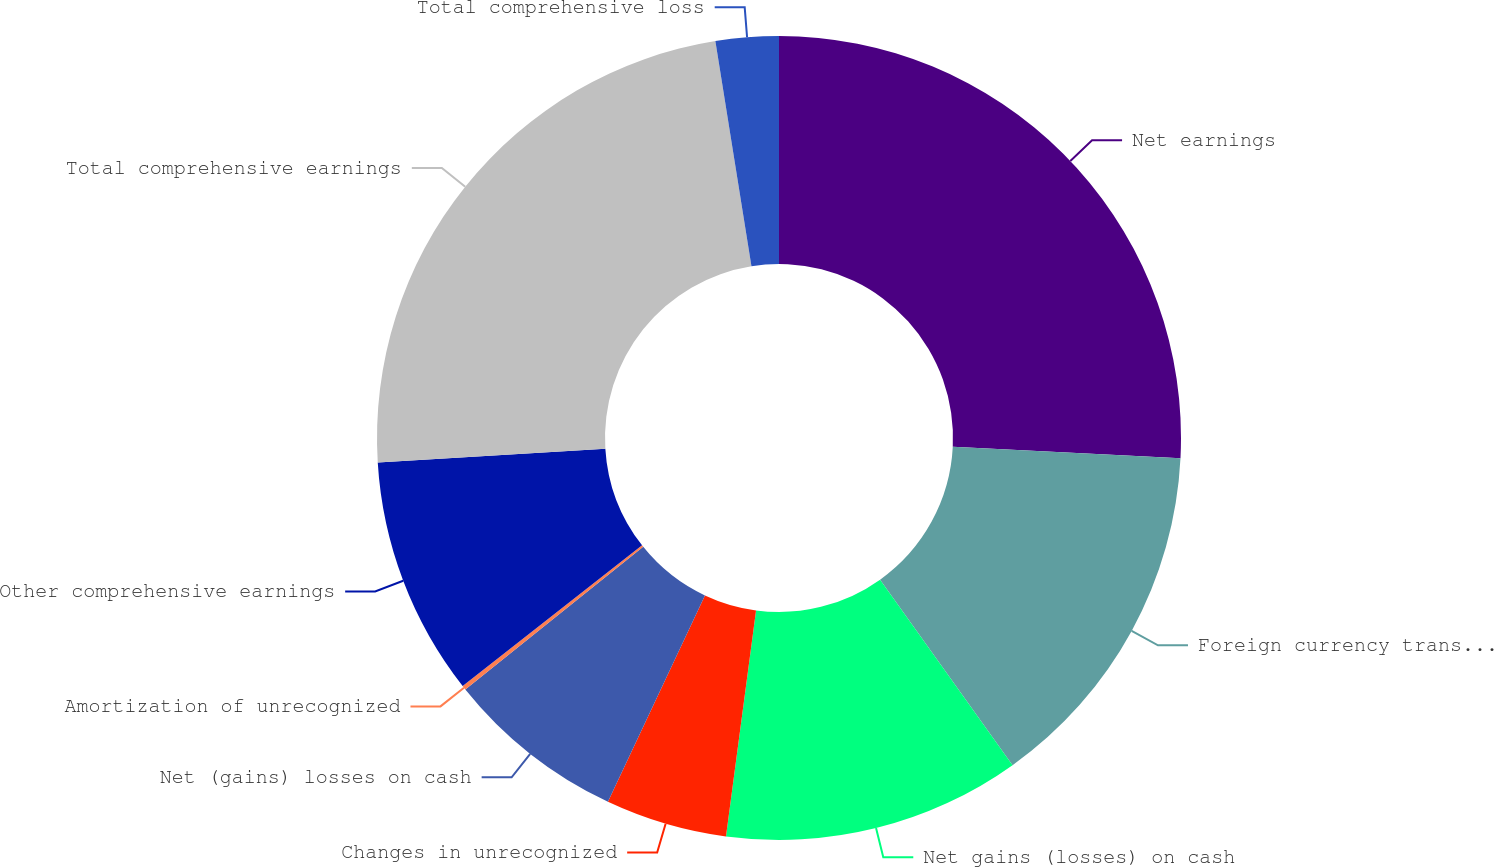Convert chart. <chart><loc_0><loc_0><loc_500><loc_500><pie_chart><fcel>Net earnings<fcel>Foreign currency translation<fcel>Net gains (losses) on cash<fcel>Changes in unrecognized<fcel>Net (gains) losses on cash<fcel>Amortization of unrecognized<fcel>Other comprehensive earnings<fcel>Total comprehensive earnings<fcel>Total comprehensive loss<nl><fcel>25.8%<fcel>14.33%<fcel>11.97%<fcel>4.89%<fcel>7.25%<fcel>0.17%<fcel>9.61%<fcel>23.44%<fcel>2.53%<nl></chart> 